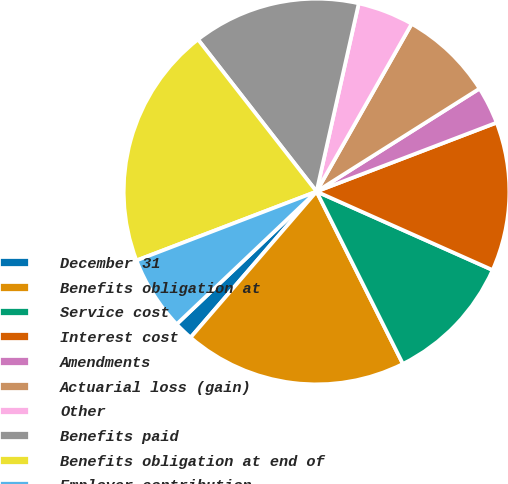Convert chart to OTSL. <chart><loc_0><loc_0><loc_500><loc_500><pie_chart><fcel>December 31<fcel>Benefits obligation at<fcel>Service cost<fcel>Interest cost<fcel>Amendments<fcel>Actuarial loss (gain)<fcel>Other<fcel>Benefits paid<fcel>Benefits obligation at end of<fcel>Employer contribution<nl><fcel>1.59%<fcel>18.72%<fcel>10.93%<fcel>12.49%<fcel>3.15%<fcel>7.82%<fcel>4.7%<fcel>14.05%<fcel>20.28%<fcel>6.26%<nl></chart> 